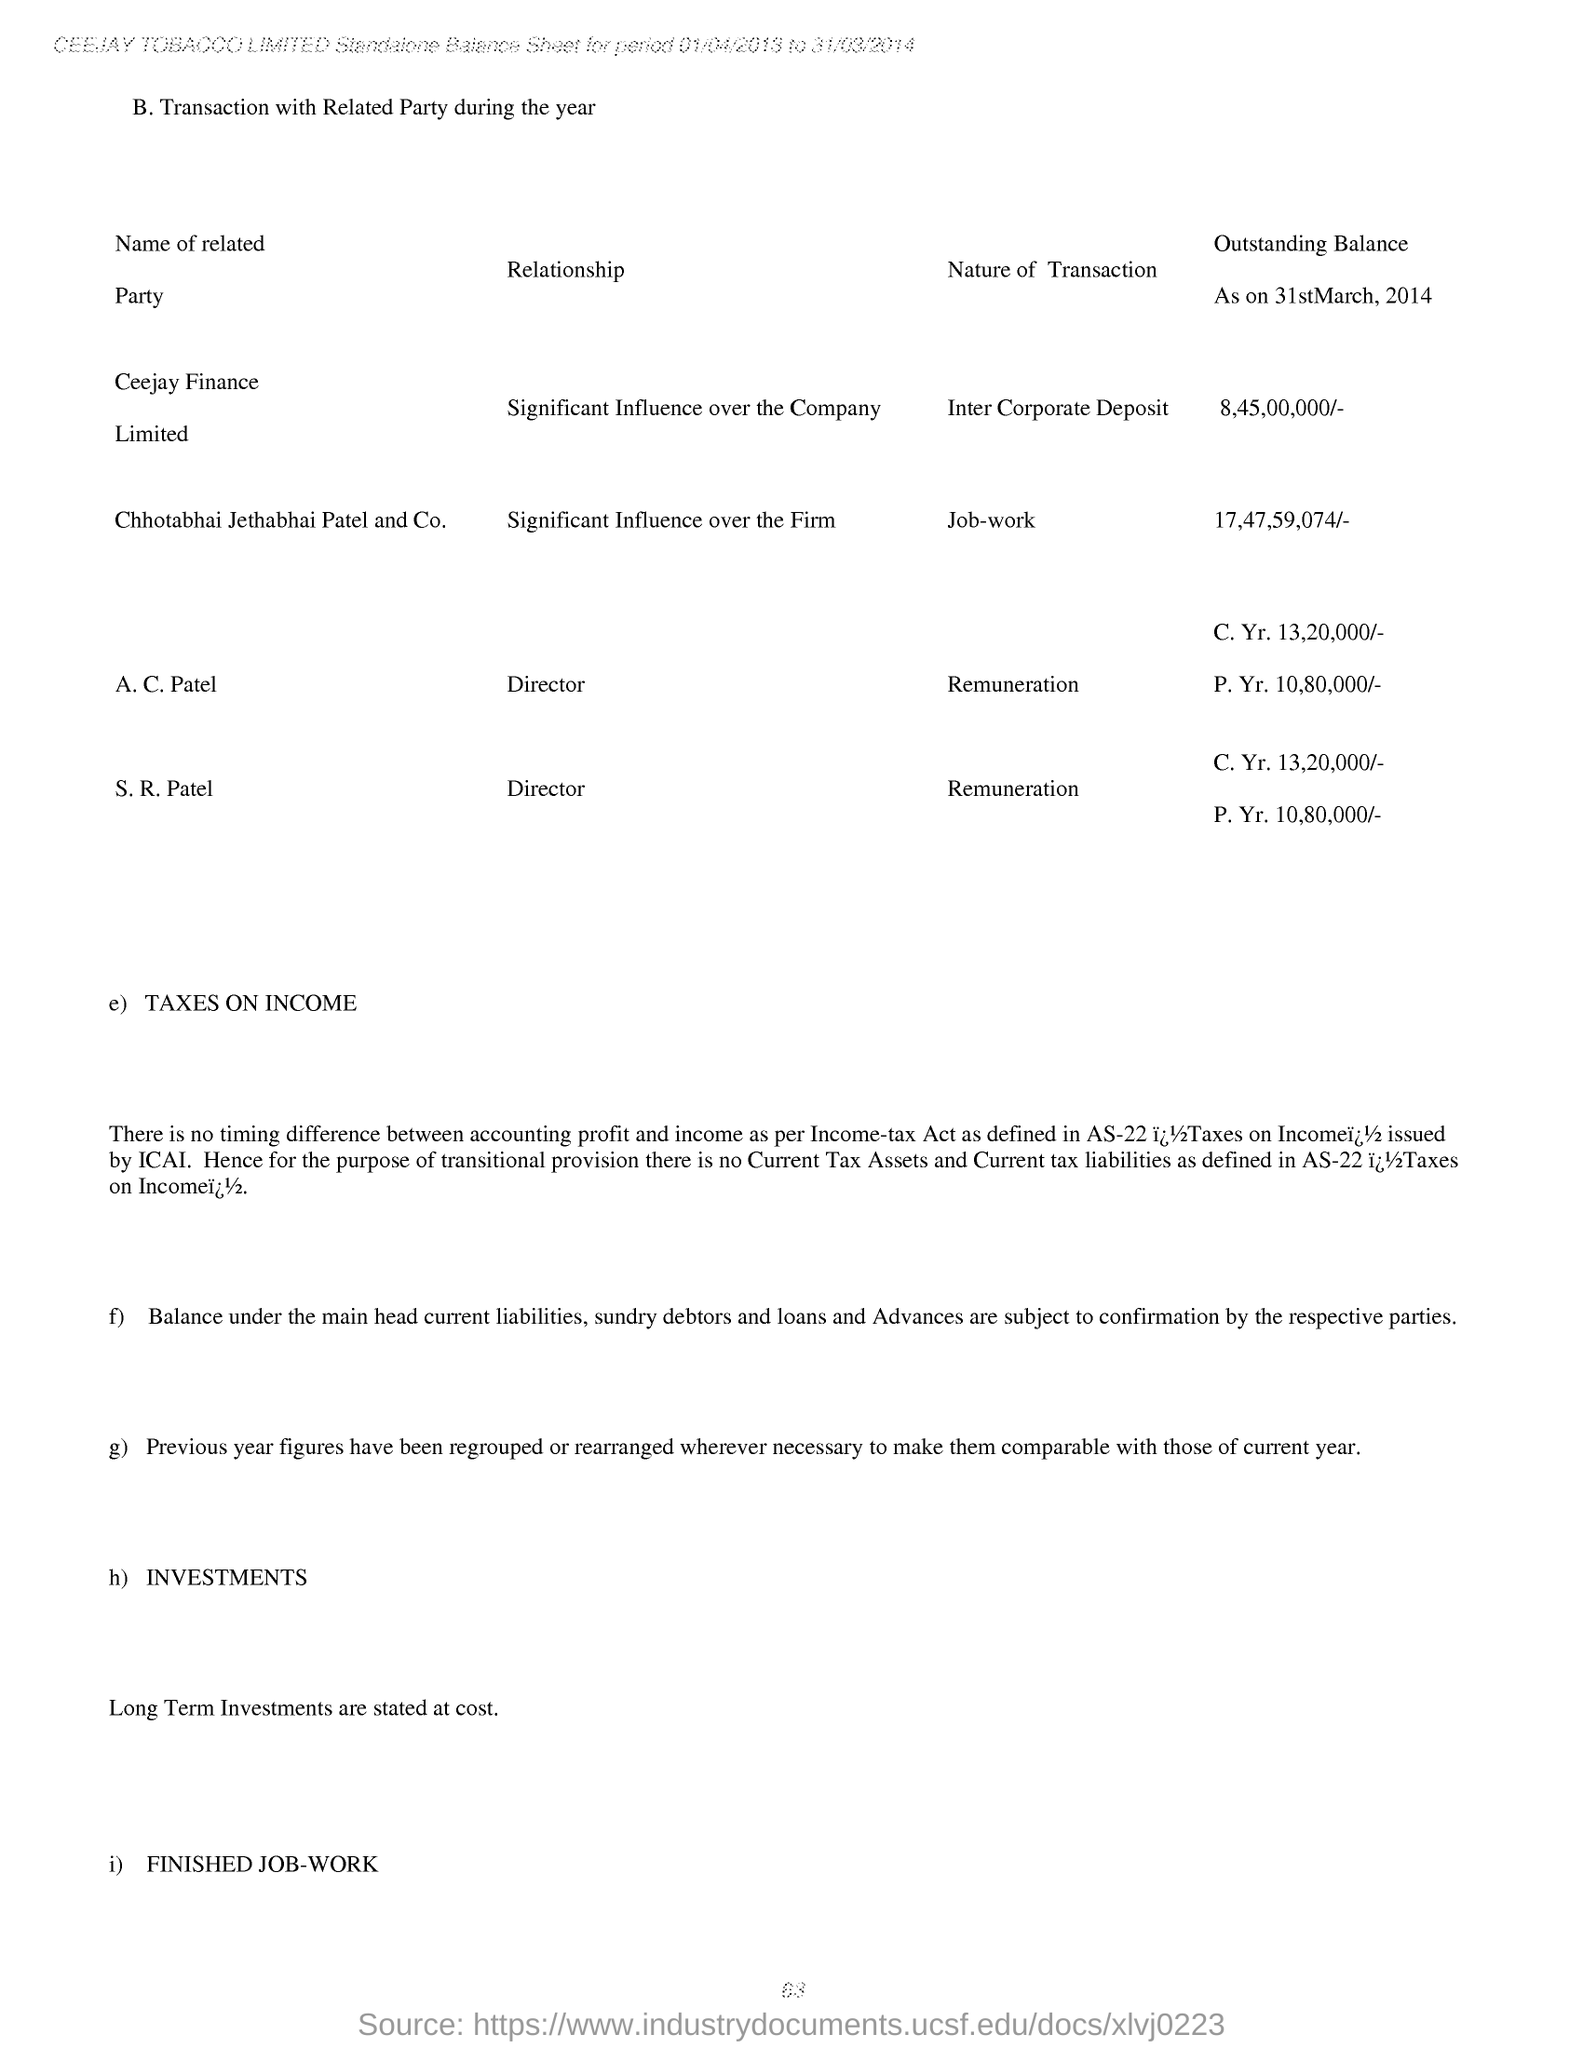What is the Designation of A. C. Patel?
Provide a short and direct response. Director. What is the designation of S. R. Patel?
Keep it short and to the point. Director. What is the outstanding balance as on 31st March, 2014 for Ceejay Finance Limited?
Ensure brevity in your answer.  8,45,00,000/-. What is the outstanding balance as on 31st March, 2014 for Chhotabhai Jethabhai Patel and Co.?
Give a very brief answer. 17,47,59,074/-. What is the Nature of Transaction mentioned for Ceejay Finance Limited?
Your answer should be very brief. Inter Corporate Deposit. 